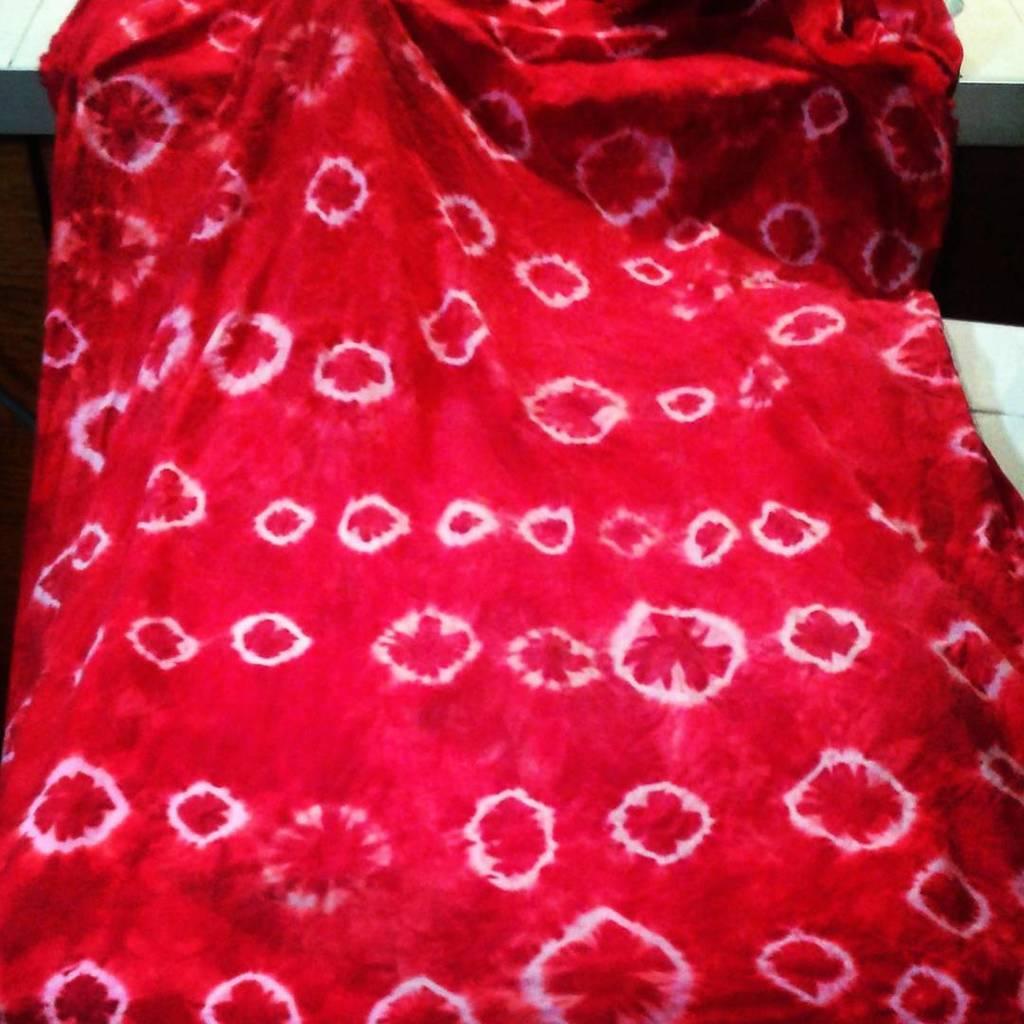How would you summarize this image in a sentence or two? In this picture we can see a red cloth on it we can see white patches. 